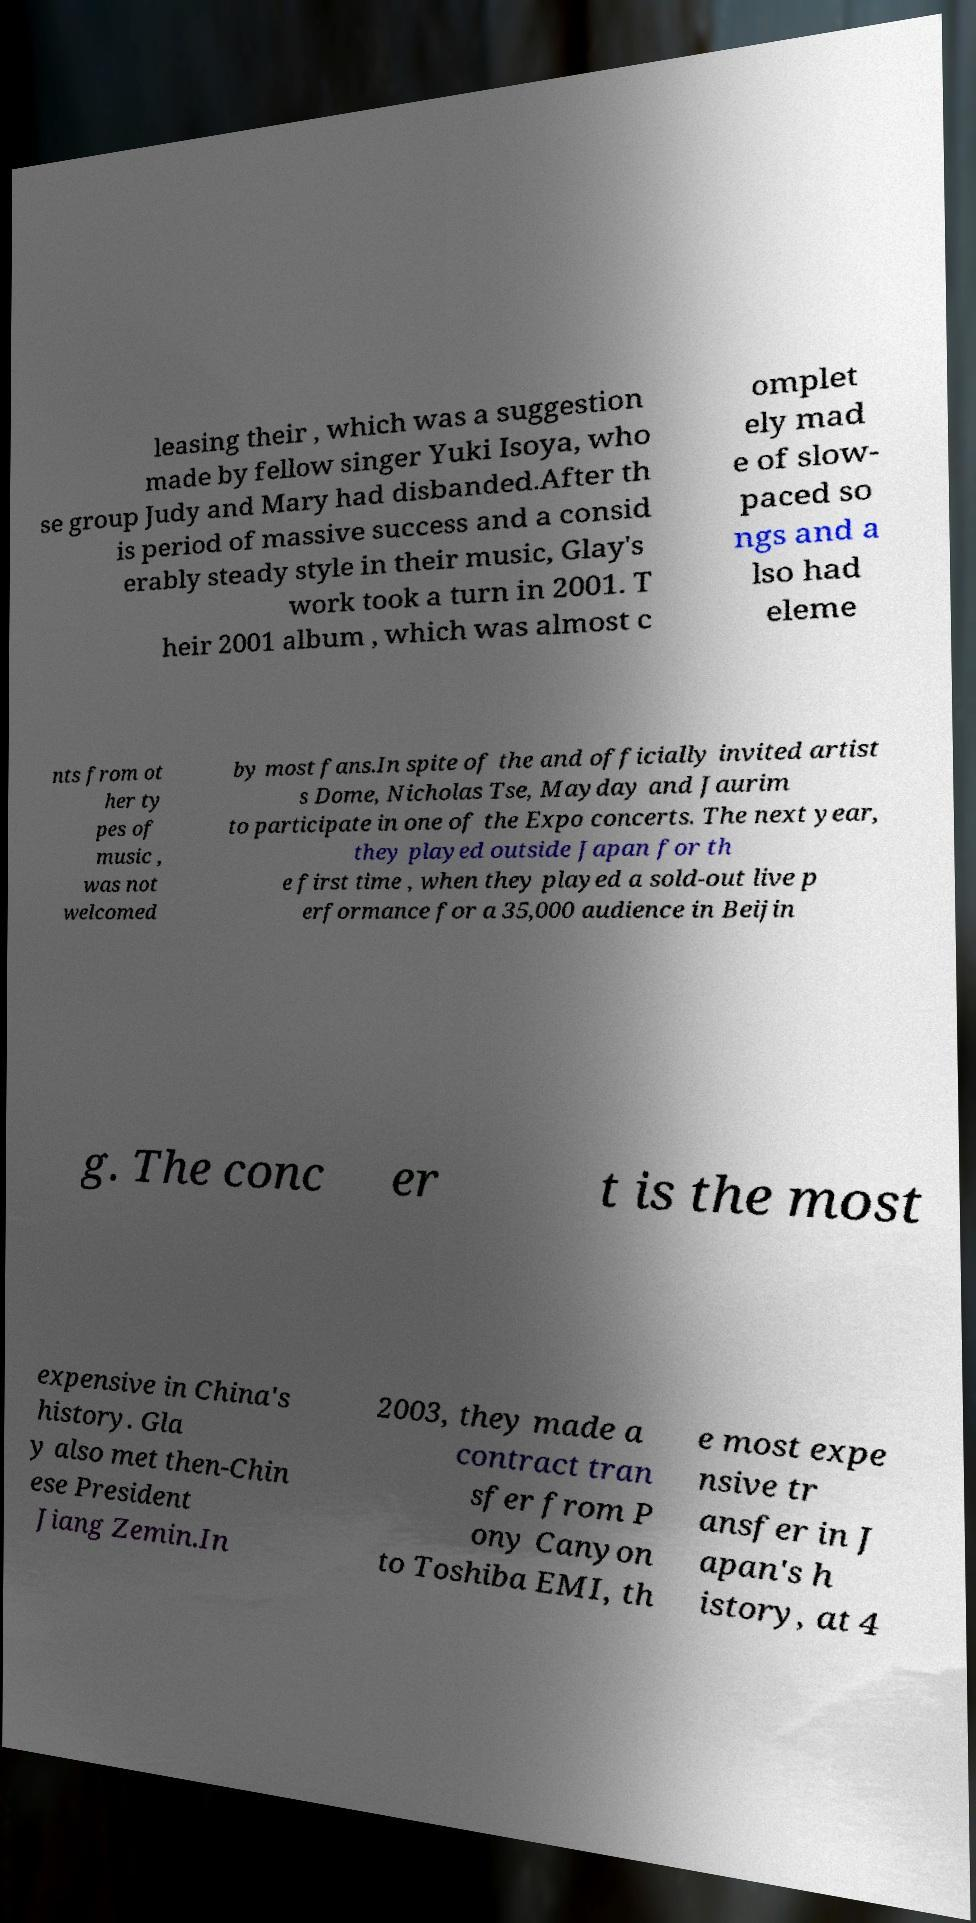For documentation purposes, I need the text within this image transcribed. Could you provide that? leasing their , which was a suggestion made by fellow singer Yuki Isoya, who se group Judy and Mary had disbanded.After th is period of massive success and a consid erably steady style in their music, Glay's work took a turn in 2001. T heir 2001 album , which was almost c omplet ely mad e of slow- paced so ngs and a lso had eleme nts from ot her ty pes of music , was not welcomed by most fans.In spite of the and officially invited artist s Dome, Nicholas Tse, Mayday and Jaurim to participate in one of the Expo concerts. The next year, they played outside Japan for th e first time , when they played a sold-out live p erformance for a 35,000 audience in Beijin g. The conc er t is the most expensive in China's history. Gla y also met then-Chin ese President Jiang Zemin.In 2003, they made a contract tran sfer from P ony Canyon to Toshiba EMI, th e most expe nsive tr ansfer in J apan's h istory, at 4 